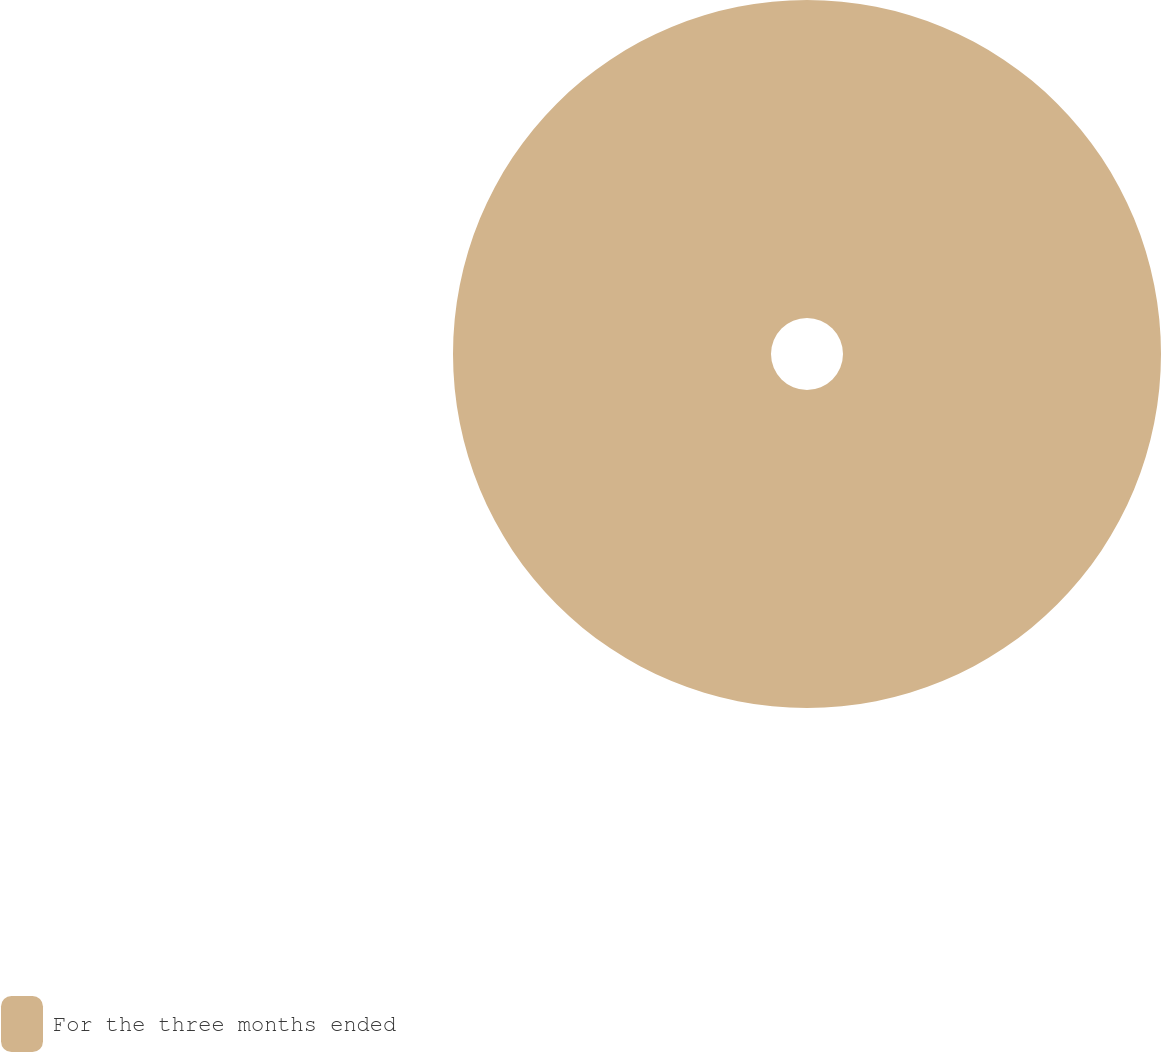Convert chart. <chart><loc_0><loc_0><loc_500><loc_500><pie_chart><fcel>For the three months ended<nl><fcel>100.0%<nl></chart> 